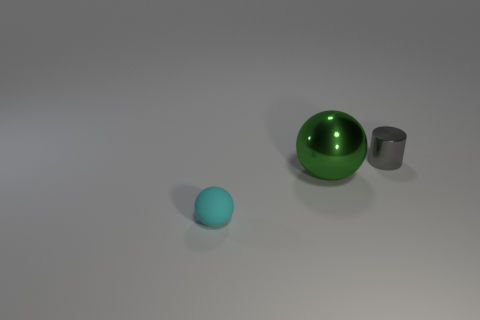Add 2 big green metallic spheres. How many objects exist? 5 Subtract all cylinders. How many objects are left? 2 Add 2 tiny metal cylinders. How many tiny metal cylinders are left? 3 Add 3 large things. How many large things exist? 4 Subtract 0 green blocks. How many objects are left? 3 Subtract all cyan spheres. Subtract all cyan things. How many objects are left? 1 